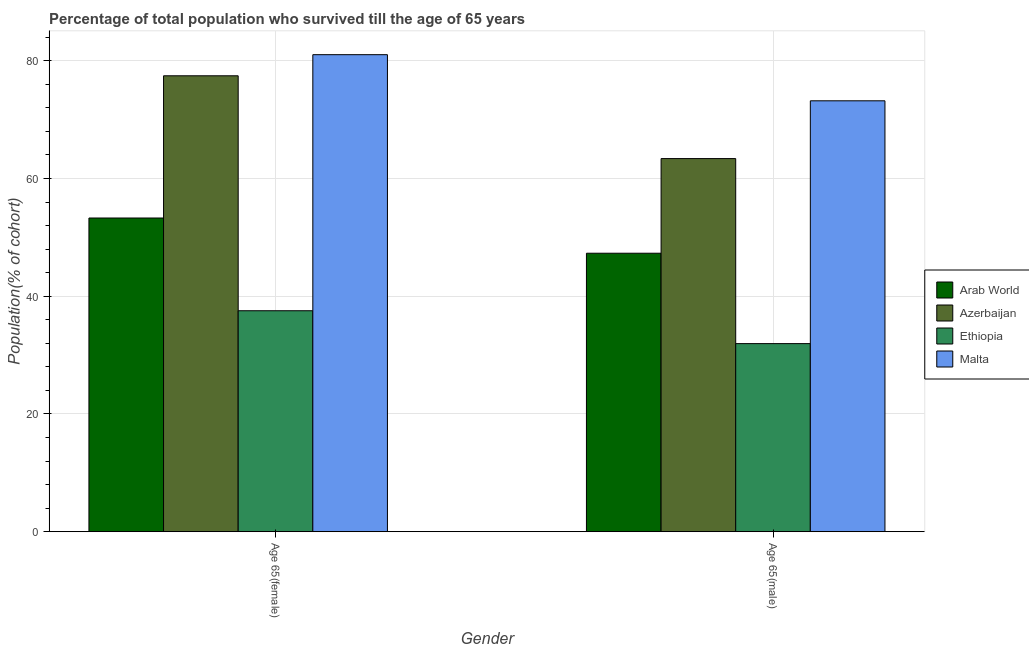How many different coloured bars are there?
Give a very brief answer. 4. Are the number of bars per tick equal to the number of legend labels?
Keep it short and to the point. Yes. How many bars are there on the 2nd tick from the right?
Offer a very short reply. 4. What is the label of the 1st group of bars from the left?
Your answer should be very brief. Age 65(female). What is the percentage of male population who survived till age of 65 in Malta?
Your response must be concise. 73.21. Across all countries, what is the maximum percentage of female population who survived till age of 65?
Offer a very short reply. 81.04. Across all countries, what is the minimum percentage of female population who survived till age of 65?
Provide a short and direct response. 37.54. In which country was the percentage of male population who survived till age of 65 maximum?
Keep it short and to the point. Malta. In which country was the percentage of male population who survived till age of 65 minimum?
Provide a short and direct response. Ethiopia. What is the total percentage of male population who survived till age of 65 in the graph?
Your answer should be compact. 215.86. What is the difference between the percentage of male population who survived till age of 65 in Malta and that in Arab World?
Ensure brevity in your answer.  25.9. What is the difference between the percentage of male population who survived till age of 65 in Azerbaijan and the percentage of female population who survived till age of 65 in Arab World?
Make the answer very short. 10.09. What is the average percentage of female population who survived till age of 65 per country?
Offer a very short reply. 62.33. What is the difference between the percentage of male population who survived till age of 65 and percentage of female population who survived till age of 65 in Malta?
Offer a very short reply. -7.84. In how many countries, is the percentage of female population who survived till age of 65 greater than 28 %?
Ensure brevity in your answer.  4. What is the ratio of the percentage of female population who survived till age of 65 in Azerbaijan to that in Arab World?
Provide a succinct answer. 1.45. What does the 1st bar from the left in Age 65(male) represents?
Offer a terse response. Arab World. What does the 3rd bar from the right in Age 65(male) represents?
Ensure brevity in your answer.  Azerbaijan. How many bars are there?
Offer a terse response. 8. What is the difference between two consecutive major ticks on the Y-axis?
Keep it short and to the point. 20. Does the graph contain any zero values?
Make the answer very short. No. Where does the legend appear in the graph?
Your response must be concise. Center right. How many legend labels are there?
Offer a very short reply. 4. How are the legend labels stacked?
Your response must be concise. Vertical. What is the title of the graph?
Provide a short and direct response. Percentage of total population who survived till the age of 65 years. What is the label or title of the X-axis?
Ensure brevity in your answer.  Gender. What is the label or title of the Y-axis?
Offer a very short reply. Population(% of cohort). What is the Population(% of cohort) of Arab World in Age 65(female)?
Offer a terse response. 53.29. What is the Population(% of cohort) in Azerbaijan in Age 65(female)?
Offer a terse response. 77.46. What is the Population(% of cohort) in Ethiopia in Age 65(female)?
Offer a very short reply. 37.54. What is the Population(% of cohort) in Malta in Age 65(female)?
Your response must be concise. 81.04. What is the Population(% of cohort) in Arab World in Age 65(male)?
Make the answer very short. 47.31. What is the Population(% of cohort) in Azerbaijan in Age 65(male)?
Your answer should be very brief. 63.39. What is the Population(% of cohort) of Ethiopia in Age 65(male)?
Ensure brevity in your answer.  31.95. What is the Population(% of cohort) in Malta in Age 65(male)?
Your response must be concise. 73.21. Across all Gender, what is the maximum Population(% of cohort) in Arab World?
Your answer should be compact. 53.29. Across all Gender, what is the maximum Population(% of cohort) in Azerbaijan?
Give a very brief answer. 77.46. Across all Gender, what is the maximum Population(% of cohort) of Ethiopia?
Provide a succinct answer. 37.54. Across all Gender, what is the maximum Population(% of cohort) of Malta?
Ensure brevity in your answer.  81.04. Across all Gender, what is the minimum Population(% of cohort) of Arab World?
Keep it short and to the point. 47.31. Across all Gender, what is the minimum Population(% of cohort) of Azerbaijan?
Offer a very short reply. 63.39. Across all Gender, what is the minimum Population(% of cohort) in Ethiopia?
Keep it short and to the point. 31.95. Across all Gender, what is the minimum Population(% of cohort) of Malta?
Offer a very short reply. 73.21. What is the total Population(% of cohort) in Arab World in the graph?
Your answer should be very brief. 100.6. What is the total Population(% of cohort) in Azerbaijan in the graph?
Give a very brief answer. 140.84. What is the total Population(% of cohort) in Ethiopia in the graph?
Offer a terse response. 69.49. What is the total Population(% of cohort) of Malta in the graph?
Your response must be concise. 154.25. What is the difference between the Population(% of cohort) of Arab World in Age 65(female) and that in Age 65(male)?
Your answer should be compact. 5.99. What is the difference between the Population(% of cohort) of Azerbaijan in Age 65(female) and that in Age 65(male)?
Ensure brevity in your answer.  14.07. What is the difference between the Population(% of cohort) of Ethiopia in Age 65(female) and that in Age 65(male)?
Offer a very short reply. 5.59. What is the difference between the Population(% of cohort) in Malta in Age 65(female) and that in Age 65(male)?
Offer a terse response. 7.84. What is the difference between the Population(% of cohort) in Arab World in Age 65(female) and the Population(% of cohort) in Azerbaijan in Age 65(male)?
Your answer should be compact. -10.09. What is the difference between the Population(% of cohort) of Arab World in Age 65(female) and the Population(% of cohort) of Ethiopia in Age 65(male)?
Provide a short and direct response. 21.34. What is the difference between the Population(% of cohort) of Arab World in Age 65(female) and the Population(% of cohort) of Malta in Age 65(male)?
Make the answer very short. -19.91. What is the difference between the Population(% of cohort) in Azerbaijan in Age 65(female) and the Population(% of cohort) in Ethiopia in Age 65(male)?
Give a very brief answer. 45.5. What is the difference between the Population(% of cohort) in Azerbaijan in Age 65(female) and the Population(% of cohort) in Malta in Age 65(male)?
Your answer should be compact. 4.25. What is the difference between the Population(% of cohort) of Ethiopia in Age 65(female) and the Population(% of cohort) of Malta in Age 65(male)?
Provide a succinct answer. -35.67. What is the average Population(% of cohort) in Arab World per Gender?
Provide a short and direct response. 50.3. What is the average Population(% of cohort) of Azerbaijan per Gender?
Offer a terse response. 70.42. What is the average Population(% of cohort) in Ethiopia per Gender?
Make the answer very short. 34.75. What is the average Population(% of cohort) in Malta per Gender?
Offer a very short reply. 77.12. What is the difference between the Population(% of cohort) of Arab World and Population(% of cohort) of Azerbaijan in Age 65(female)?
Provide a succinct answer. -24.16. What is the difference between the Population(% of cohort) in Arab World and Population(% of cohort) in Ethiopia in Age 65(female)?
Provide a succinct answer. 15.75. What is the difference between the Population(% of cohort) of Arab World and Population(% of cohort) of Malta in Age 65(female)?
Provide a short and direct response. -27.75. What is the difference between the Population(% of cohort) of Azerbaijan and Population(% of cohort) of Ethiopia in Age 65(female)?
Keep it short and to the point. 39.92. What is the difference between the Population(% of cohort) in Azerbaijan and Population(% of cohort) in Malta in Age 65(female)?
Offer a terse response. -3.59. What is the difference between the Population(% of cohort) of Ethiopia and Population(% of cohort) of Malta in Age 65(female)?
Give a very brief answer. -43.5. What is the difference between the Population(% of cohort) in Arab World and Population(% of cohort) in Azerbaijan in Age 65(male)?
Give a very brief answer. -16.08. What is the difference between the Population(% of cohort) in Arab World and Population(% of cohort) in Ethiopia in Age 65(male)?
Provide a short and direct response. 15.36. What is the difference between the Population(% of cohort) of Arab World and Population(% of cohort) of Malta in Age 65(male)?
Give a very brief answer. -25.9. What is the difference between the Population(% of cohort) of Azerbaijan and Population(% of cohort) of Ethiopia in Age 65(male)?
Your answer should be compact. 31.44. What is the difference between the Population(% of cohort) in Azerbaijan and Population(% of cohort) in Malta in Age 65(male)?
Make the answer very short. -9.82. What is the difference between the Population(% of cohort) of Ethiopia and Population(% of cohort) of Malta in Age 65(male)?
Your answer should be compact. -41.25. What is the ratio of the Population(% of cohort) of Arab World in Age 65(female) to that in Age 65(male)?
Offer a very short reply. 1.13. What is the ratio of the Population(% of cohort) of Azerbaijan in Age 65(female) to that in Age 65(male)?
Provide a succinct answer. 1.22. What is the ratio of the Population(% of cohort) of Ethiopia in Age 65(female) to that in Age 65(male)?
Keep it short and to the point. 1.17. What is the ratio of the Population(% of cohort) of Malta in Age 65(female) to that in Age 65(male)?
Make the answer very short. 1.11. What is the difference between the highest and the second highest Population(% of cohort) in Arab World?
Your answer should be compact. 5.99. What is the difference between the highest and the second highest Population(% of cohort) of Azerbaijan?
Provide a short and direct response. 14.07. What is the difference between the highest and the second highest Population(% of cohort) of Ethiopia?
Your answer should be very brief. 5.59. What is the difference between the highest and the second highest Population(% of cohort) of Malta?
Offer a very short reply. 7.84. What is the difference between the highest and the lowest Population(% of cohort) of Arab World?
Your answer should be very brief. 5.99. What is the difference between the highest and the lowest Population(% of cohort) of Azerbaijan?
Make the answer very short. 14.07. What is the difference between the highest and the lowest Population(% of cohort) of Ethiopia?
Keep it short and to the point. 5.59. What is the difference between the highest and the lowest Population(% of cohort) of Malta?
Give a very brief answer. 7.84. 